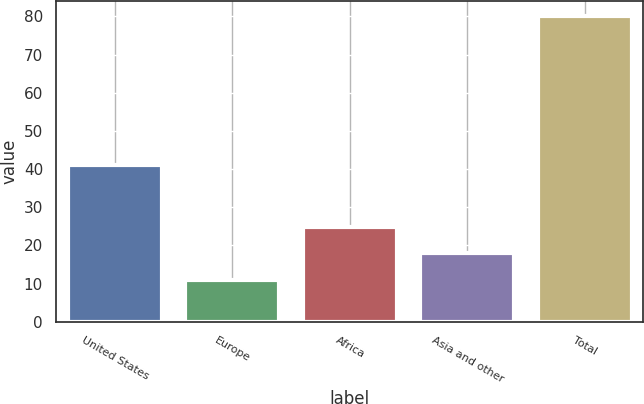<chart> <loc_0><loc_0><loc_500><loc_500><bar_chart><fcel>United States<fcel>Europe<fcel>Africa<fcel>Asia and other<fcel>Total<nl><fcel>41<fcel>11<fcel>24.8<fcel>17.9<fcel>80<nl></chart> 